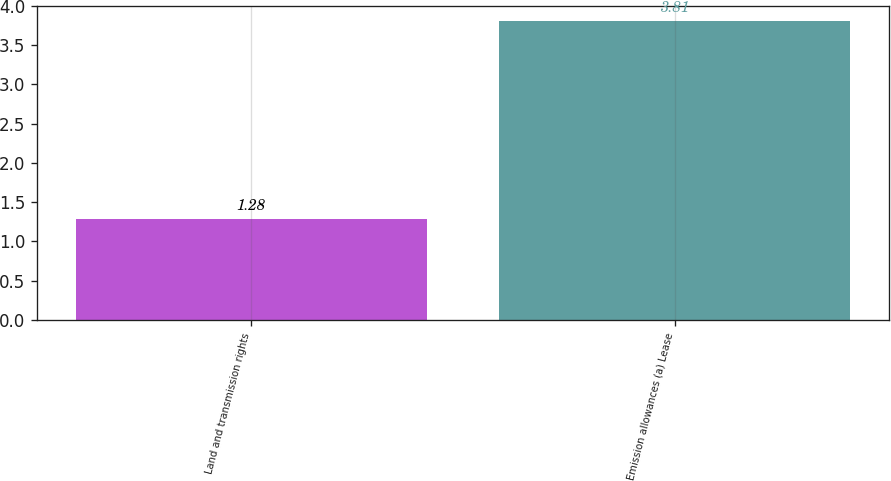Convert chart. <chart><loc_0><loc_0><loc_500><loc_500><bar_chart><fcel>Land and transmission rights<fcel>Emission allowances (a) Lease<nl><fcel>1.28<fcel>3.81<nl></chart> 